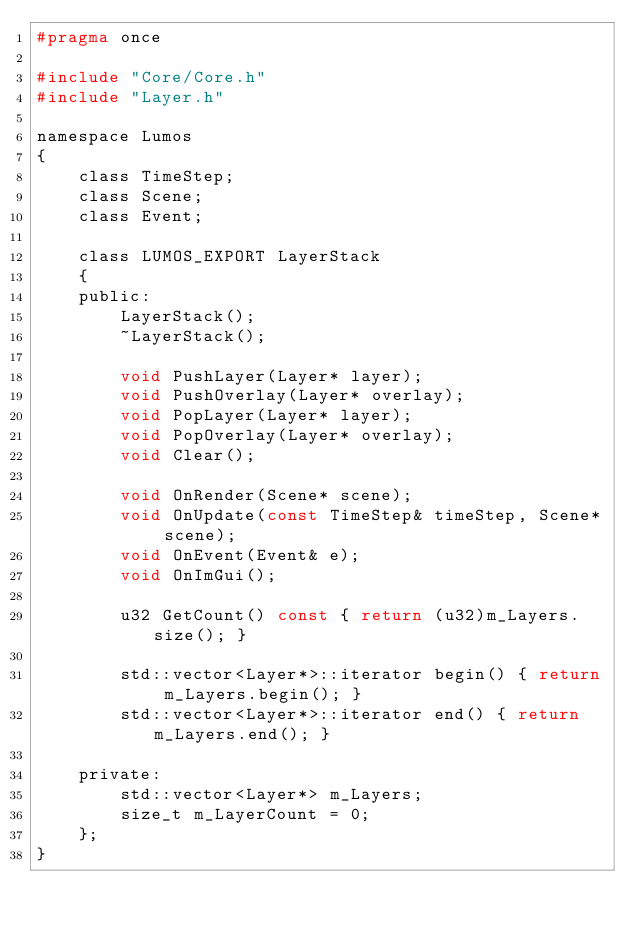<code> <loc_0><loc_0><loc_500><loc_500><_C_>#pragma once

#include "Core/Core.h"
#include "Layer.h"

namespace Lumos
{
	class TimeStep;
	class Scene;
	class Event;

	class LUMOS_EXPORT LayerStack
	{
	public:
		LayerStack();
		~LayerStack();

		void PushLayer(Layer* layer);
		void PushOverlay(Layer* overlay);
		void PopLayer(Layer* layer);
		void PopOverlay(Layer* overlay);
		void Clear();

		void OnRender(Scene* scene);
		void OnUpdate(const TimeStep& timeStep, Scene* scene);
		void OnEvent(Event& e);
		void OnImGui();

		u32 GetCount() const { return (u32)m_Layers.size(); }
        
        std::vector<Layer*>::iterator begin() { return m_Layers.begin(); }
        std::vector<Layer*>::iterator end() { return m_Layers.end(); }

	private:
        std::vector<Layer*> m_Layers;
		size_t m_LayerCount = 0;
	};
}
</code> 